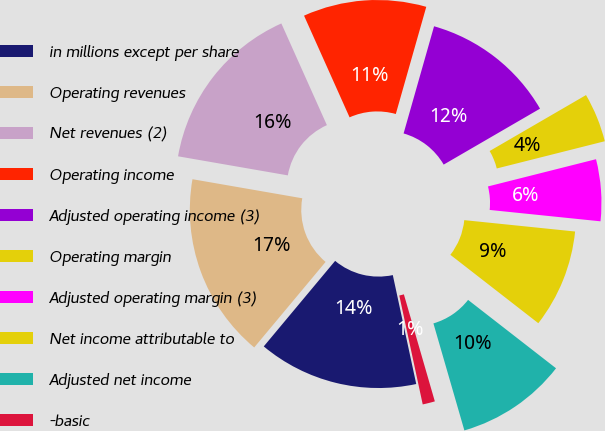Convert chart to OTSL. <chart><loc_0><loc_0><loc_500><loc_500><pie_chart><fcel>in millions except per share<fcel>Operating revenues<fcel>Net revenues (2)<fcel>Operating income<fcel>Adjusted operating income (3)<fcel>Operating margin<fcel>Adjusted operating margin (3)<fcel>Net income attributable to<fcel>Adjusted net income<fcel>-basic<nl><fcel>14.44%<fcel>16.67%<fcel>15.56%<fcel>11.11%<fcel>12.22%<fcel>4.44%<fcel>5.56%<fcel>8.89%<fcel>10.0%<fcel>1.11%<nl></chart> 